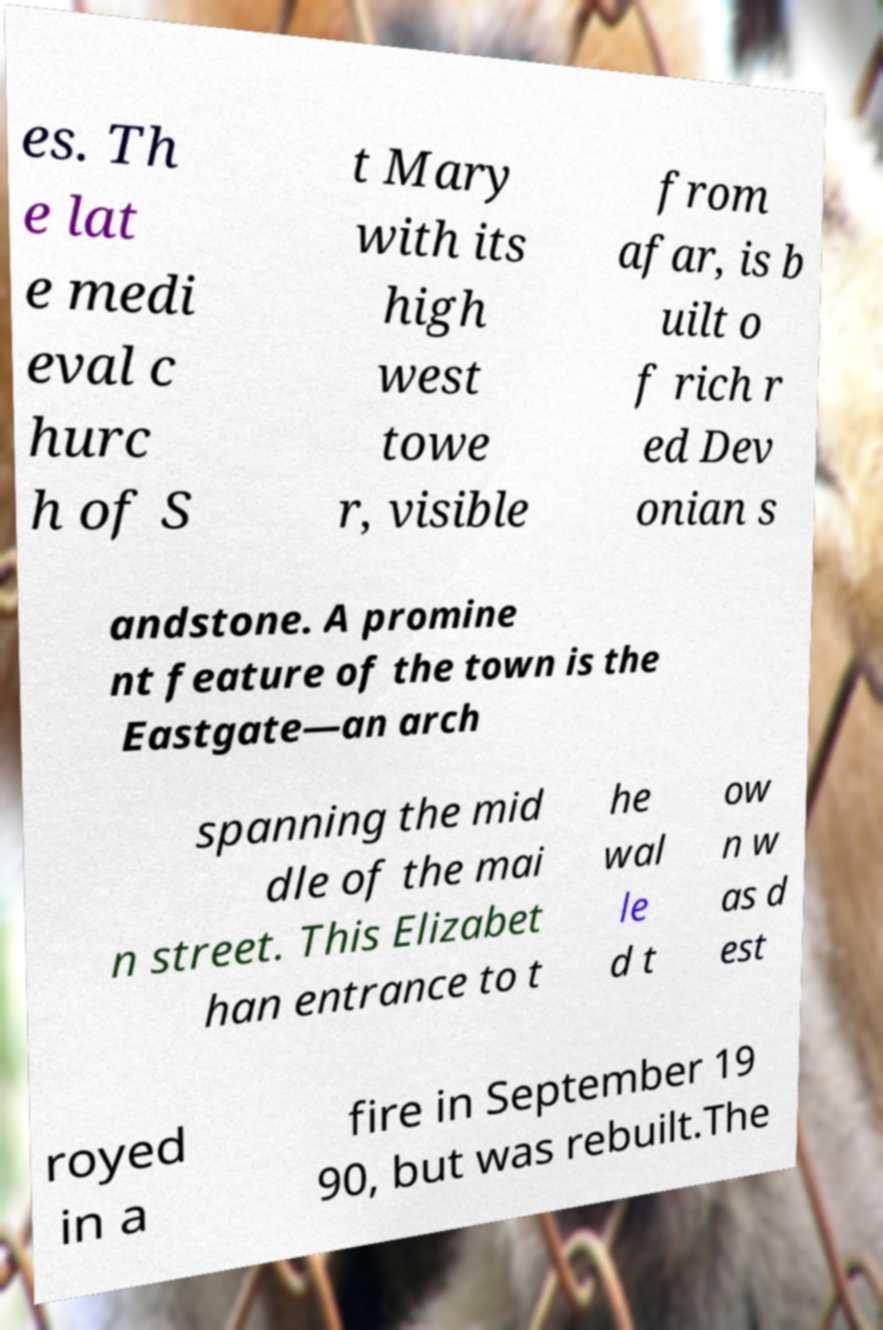Please read and relay the text visible in this image. What does it say? es. Th e lat e medi eval c hurc h of S t Mary with its high west towe r, visible from afar, is b uilt o f rich r ed Dev onian s andstone. A promine nt feature of the town is the Eastgate—an arch spanning the mid dle of the mai n street. This Elizabet han entrance to t he wal le d t ow n w as d est royed in a fire in September 19 90, but was rebuilt.The 